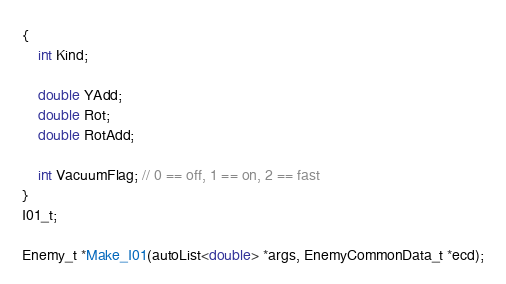<code> <loc_0><loc_0><loc_500><loc_500><_C_>{
	int Kind;

	double YAdd;
	double Rot;
	double RotAdd;

	int VacuumFlag; // 0 == off, 1 == on, 2 == fast
}
I01_t;

Enemy_t *Make_I01(autoList<double> *args, EnemyCommonData_t *ecd);
</code> 